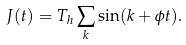Convert formula to latex. <formula><loc_0><loc_0><loc_500><loc_500>J ( t ) = T _ { h } \sum _ { k } \sin ( k + \phi t ) .</formula> 